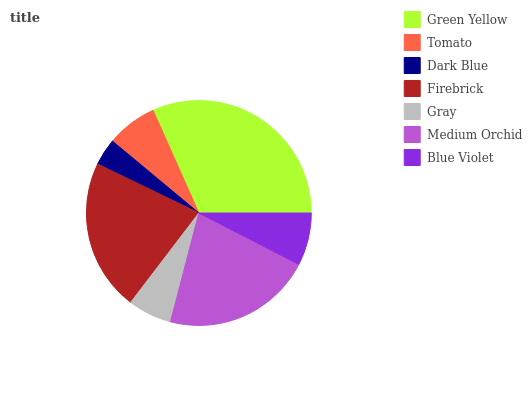Is Dark Blue the minimum?
Answer yes or no. Yes. Is Green Yellow the maximum?
Answer yes or no. Yes. Is Tomato the minimum?
Answer yes or no. No. Is Tomato the maximum?
Answer yes or no. No. Is Green Yellow greater than Tomato?
Answer yes or no. Yes. Is Tomato less than Green Yellow?
Answer yes or no. Yes. Is Tomato greater than Green Yellow?
Answer yes or no. No. Is Green Yellow less than Tomato?
Answer yes or no. No. Is Blue Violet the high median?
Answer yes or no. Yes. Is Blue Violet the low median?
Answer yes or no. Yes. Is Green Yellow the high median?
Answer yes or no. No. Is Green Yellow the low median?
Answer yes or no. No. 